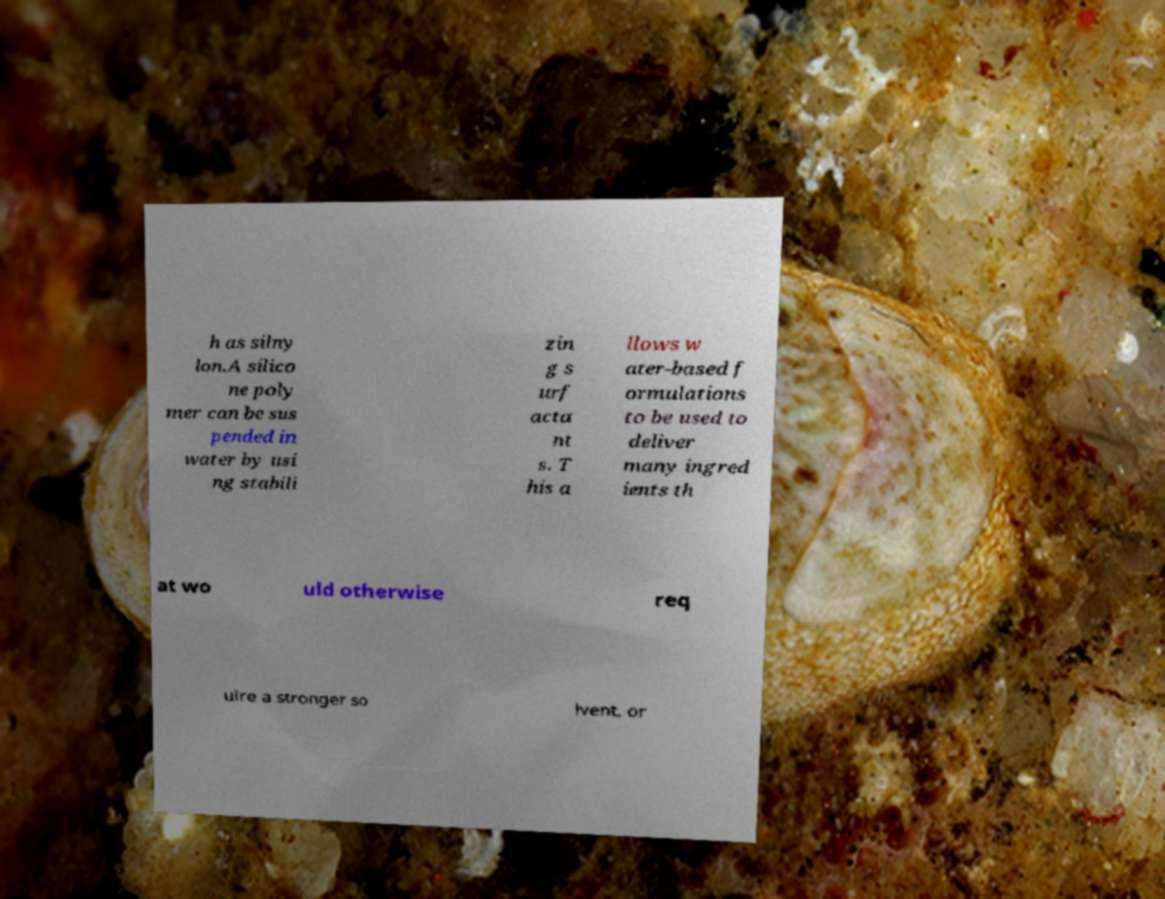Can you accurately transcribe the text from the provided image for me? h as silny lon.A silico ne poly mer can be sus pended in water by usi ng stabili zin g s urf acta nt s. T his a llows w ater-based f ormulations to be used to deliver many ingred ients th at wo uld otherwise req uire a stronger so lvent, or 